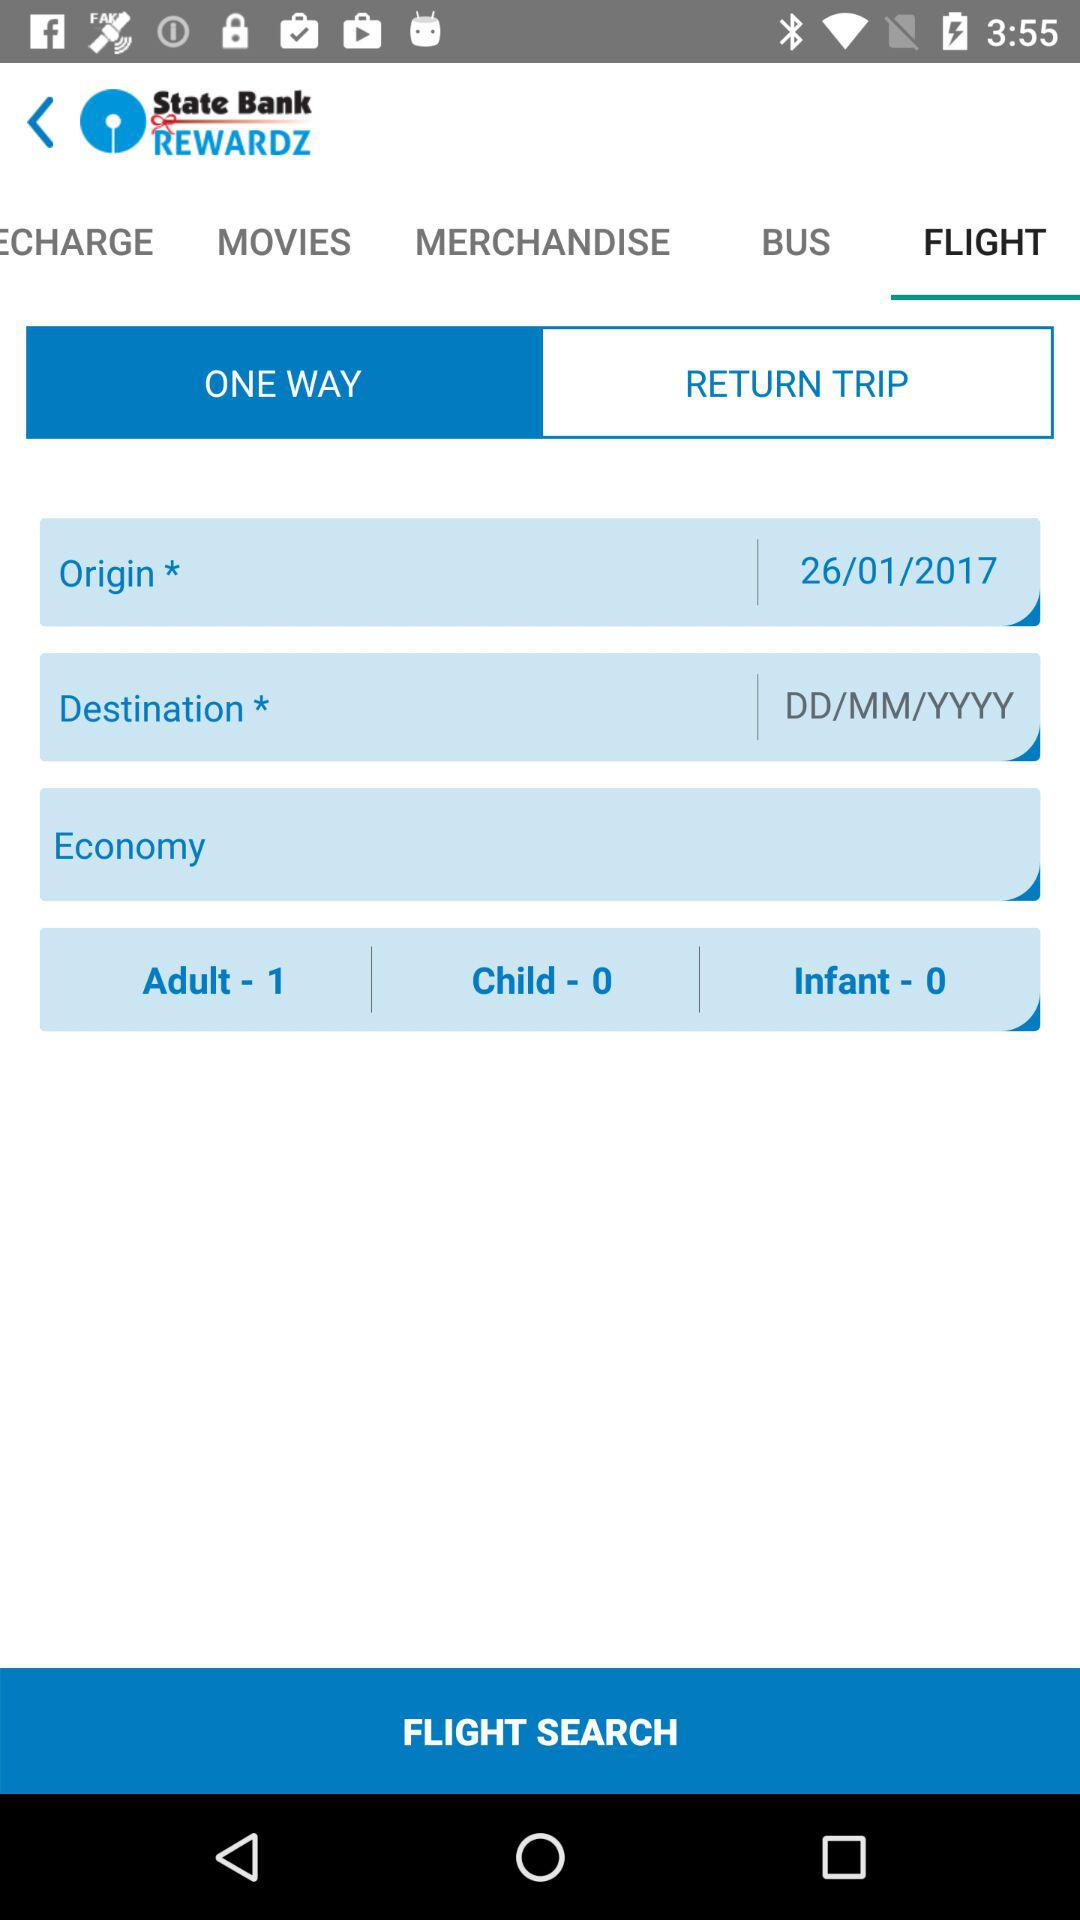How many more adults than infants are in the flight search?
Answer the question using a single word or phrase. 1 